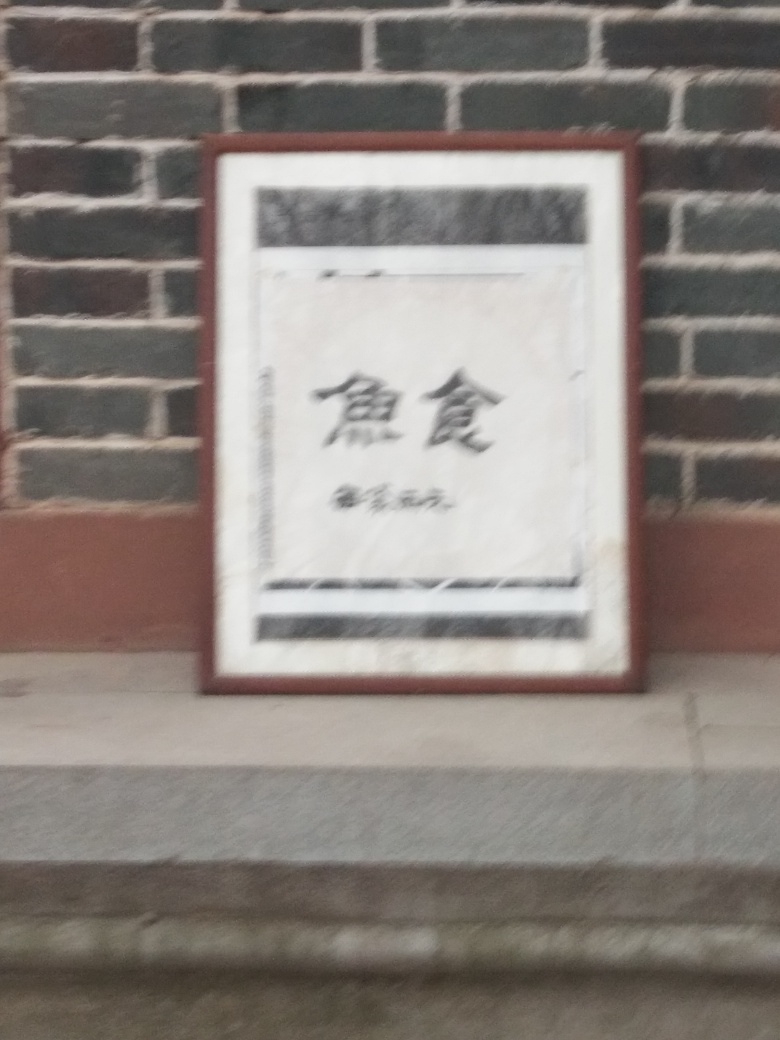What does the setting of this image suggest about the location where it was taken? The setting includes a brick wall and a framed sign, suggesting it may be a part of a structured outdoor area, such as a historic district or a cultural venue. The style of the sign frame and appearance of the wall could hint at a location with traditional or heritage significance. 